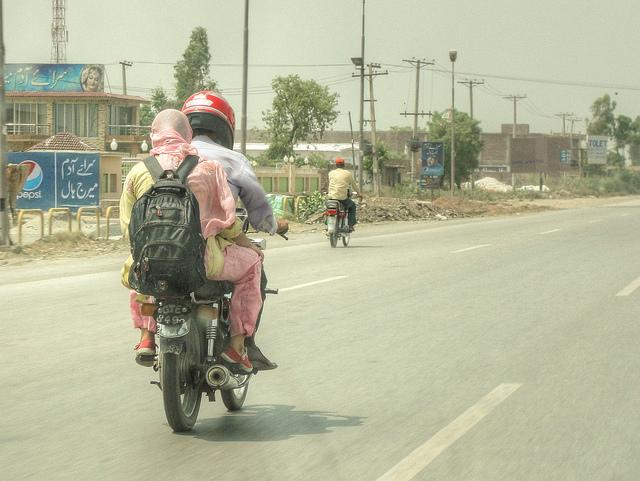Why is the air so hazy?

Choices:
A) fire
B) factory smoke
C) smog
D) fog smog 